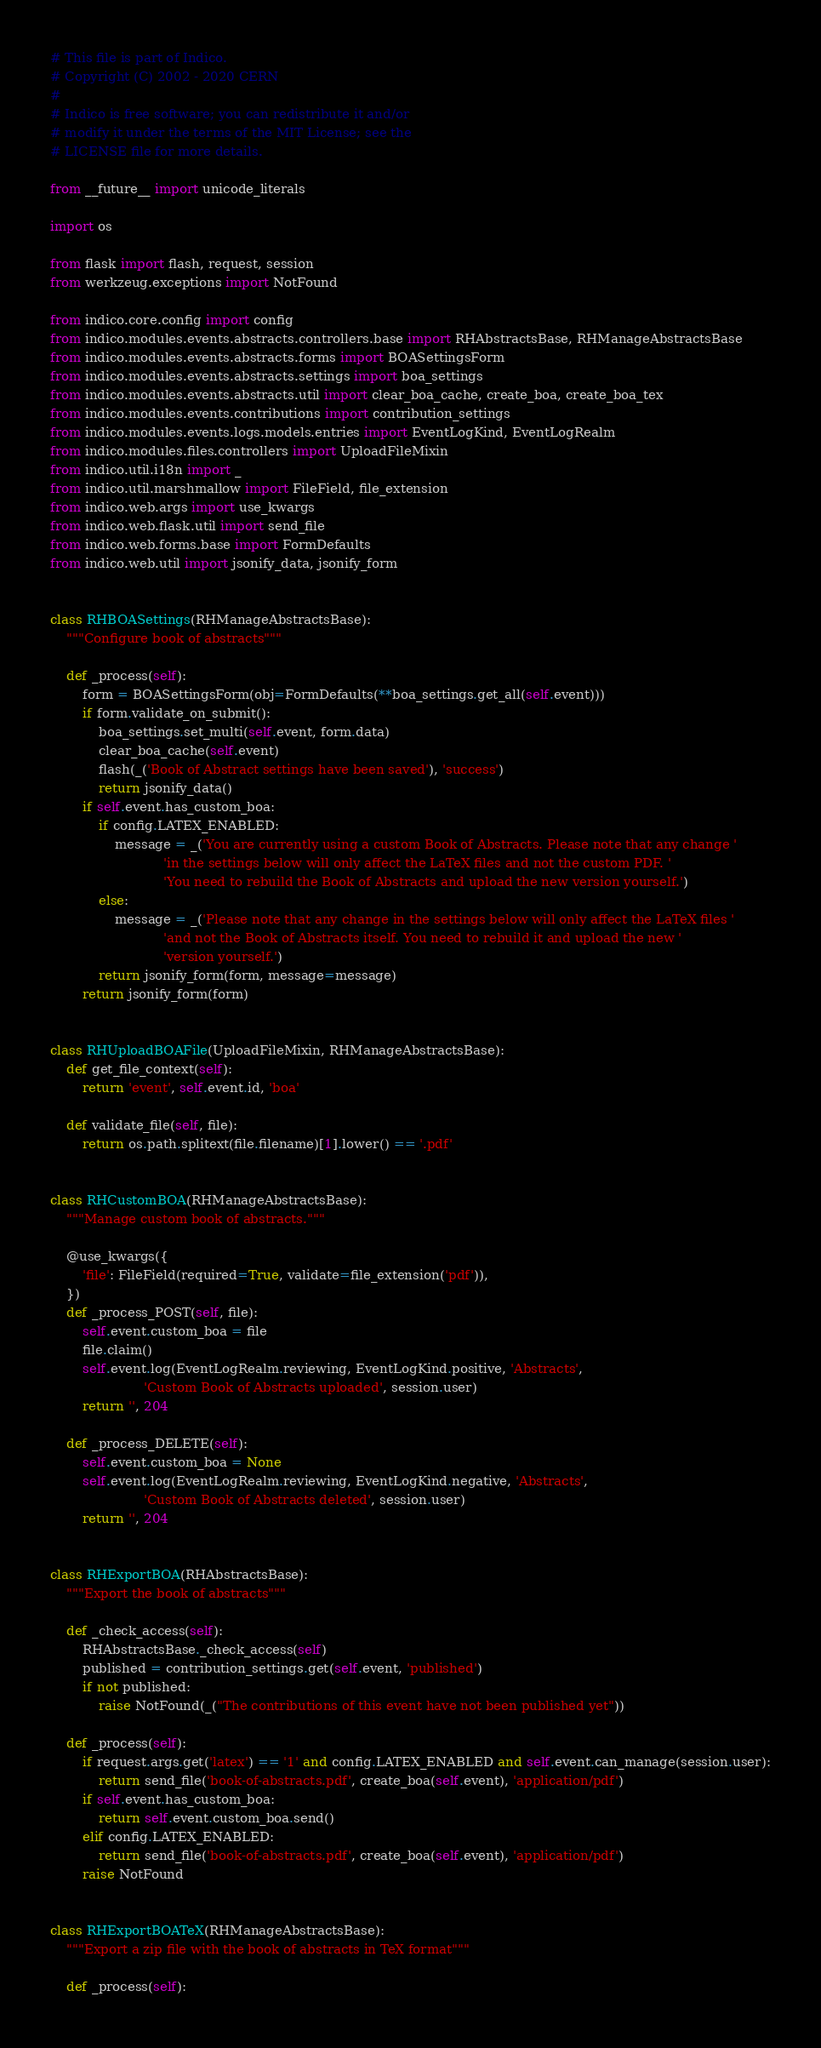Convert code to text. <code><loc_0><loc_0><loc_500><loc_500><_Python_># This file is part of Indico.
# Copyright (C) 2002 - 2020 CERN
#
# Indico is free software; you can redistribute it and/or
# modify it under the terms of the MIT License; see the
# LICENSE file for more details.

from __future__ import unicode_literals

import os

from flask import flash, request, session
from werkzeug.exceptions import NotFound

from indico.core.config import config
from indico.modules.events.abstracts.controllers.base import RHAbstractsBase, RHManageAbstractsBase
from indico.modules.events.abstracts.forms import BOASettingsForm
from indico.modules.events.abstracts.settings import boa_settings
from indico.modules.events.abstracts.util import clear_boa_cache, create_boa, create_boa_tex
from indico.modules.events.contributions import contribution_settings
from indico.modules.events.logs.models.entries import EventLogKind, EventLogRealm
from indico.modules.files.controllers import UploadFileMixin
from indico.util.i18n import _
from indico.util.marshmallow import FileField, file_extension
from indico.web.args import use_kwargs
from indico.web.flask.util import send_file
from indico.web.forms.base import FormDefaults
from indico.web.util import jsonify_data, jsonify_form


class RHBOASettings(RHManageAbstractsBase):
    """Configure book of abstracts"""

    def _process(self):
        form = BOASettingsForm(obj=FormDefaults(**boa_settings.get_all(self.event)))
        if form.validate_on_submit():
            boa_settings.set_multi(self.event, form.data)
            clear_boa_cache(self.event)
            flash(_('Book of Abstract settings have been saved'), 'success')
            return jsonify_data()
        if self.event.has_custom_boa:
            if config.LATEX_ENABLED:
                message = _('You are currently using a custom Book of Abstracts. Please note that any change '
                            'in the settings below will only affect the LaTeX files and not the custom PDF. '
                            'You need to rebuild the Book of Abstracts and upload the new version yourself.')
            else:
                message = _('Please note that any change in the settings below will only affect the LaTeX files '
                            'and not the Book of Abstracts itself. You need to rebuild it and upload the new '
                            'version yourself.')
            return jsonify_form(form, message=message)
        return jsonify_form(form)


class RHUploadBOAFile(UploadFileMixin, RHManageAbstractsBase):
    def get_file_context(self):
        return 'event', self.event.id, 'boa'

    def validate_file(self, file):
        return os.path.splitext(file.filename)[1].lower() == '.pdf'


class RHCustomBOA(RHManageAbstractsBase):
    """Manage custom book of abstracts."""

    @use_kwargs({
        'file': FileField(required=True, validate=file_extension('pdf')),
    })
    def _process_POST(self, file):
        self.event.custom_boa = file
        file.claim()
        self.event.log(EventLogRealm.reviewing, EventLogKind.positive, 'Abstracts',
                       'Custom Book of Abstracts uploaded', session.user)
        return '', 204

    def _process_DELETE(self):
        self.event.custom_boa = None
        self.event.log(EventLogRealm.reviewing, EventLogKind.negative, 'Abstracts',
                       'Custom Book of Abstracts deleted', session.user)
        return '', 204


class RHExportBOA(RHAbstractsBase):
    """Export the book of abstracts"""

    def _check_access(self):
        RHAbstractsBase._check_access(self)
        published = contribution_settings.get(self.event, 'published')
        if not published:
            raise NotFound(_("The contributions of this event have not been published yet"))

    def _process(self):
        if request.args.get('latex') == '1' and config.LATEX_ENABLED and self.event.can_manage(session.user):
            return send_file('book-of-abstracts.pdf', create_boa(self.event), 'application/pdf')
        if self.event.has_custom_boa:
            return self.event.custom_boa.send()
        elif config.LATEX_ENABLED:
            return send_file('book-of-abstracts.pdf', create_boa(self.event), 'application/pdf')
        raise NotFound


class RHExportBOATeX(RHManageAbstractsBase):
    """Export a zip file with the book of abstracts in TeX format"""

    def _process(self):</code> 